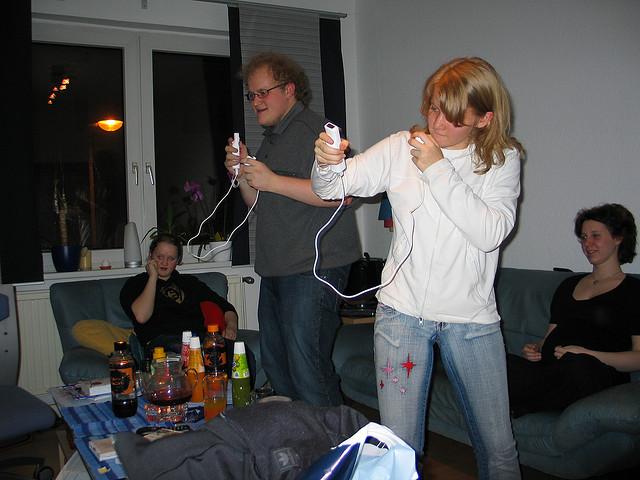Does the blonde have her hair in a ponytail?
Be succinct. No. Is there a lot of drinks on the table?
Be succinct. Yes. Was this photo taken inside or outside?
Quick response, please. Inside. How many places to sit are there?
Keep it brief. 2. Are they playing the video games drunk?
Answer briefly. No. What are the girls looking at?
Write a very short answer. Tv. Are the windows open?
Keep it brief. No. 